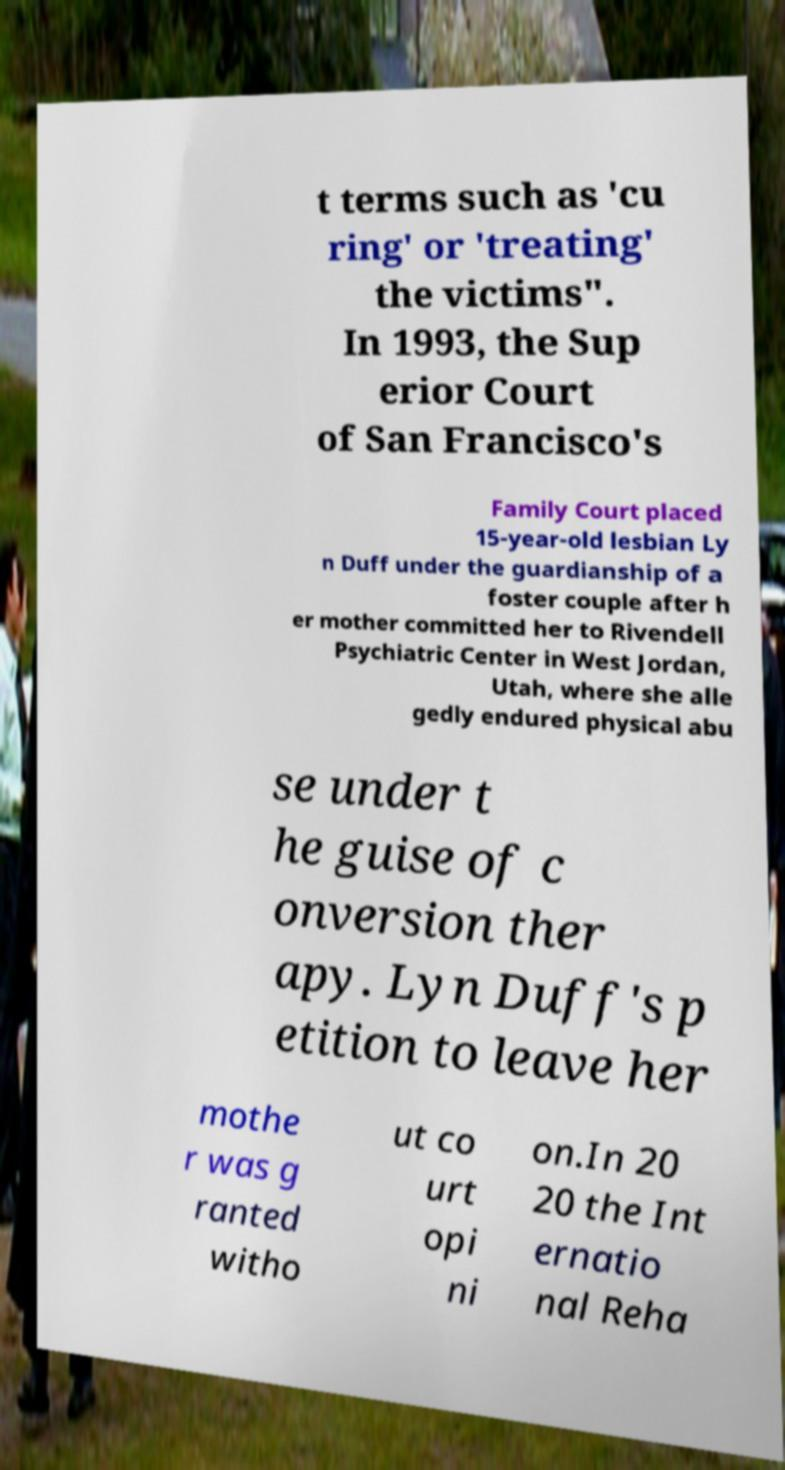Could you assist in decoding the text presented in this image and type it out clearly? t terms such as 'cu ring' or 'treating' the victims". In 1993, the Sup erior Court of San Francisco's Family Court placed 15-year-old lesbian Ly n Duff under the guardianship of a foster couple after h er mother committed her to Rivendell Psychiatric Center in West Jordan, Utah, where she alle gedly endured physical abu se under t he guise of c onversion ther apy. Lyn Duff's p etition to leave her mothe r was g ranted witho ut co urt opi ni on.In 20 20 the Int ernatio nal Reha 